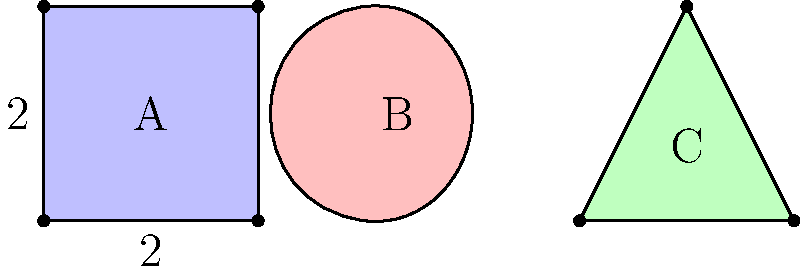In the context of comparing different possible universe configurations in the string theory landscape, consider the three irregular shapes A, B, and C shown above. Shape A is a square with side length 2 units, B is a curved triangle, and C is an isosceles triangle. If the area of shape B is $\frac{3\pi}{4}$ square units, and the area of shape C is $2\sqrt{3}$ square units, rank these shapes in order of increasing area. How does this ranking relate to the concept of comparing different universe configurations in string theory? To solve this problem, we need to calculate or compare the areas of the three shapes:

1. Shape A (Square):
   Area = side length² = 2² = 4 square units

2. Shape B (Curved triangle):
   Given area = $\frac{3\pi}{4}$ ≈ 2.356 square units

3. Shape C (Isosceles triangle):
   Given area = $2\sqrt{3}$ ≈ 3.464 square units

Ranking in order of increasing area:
B < C < A

This ranking relates to comparing different universe configurations in string theory as follows:

1. Each shape represents a possible universe configuration in the string theory landscape.
2. The area of each shape is analogous to a measure of the physical properties or parameters of each universe configuration.
3. Comparing areas is similar to comparing the likelihood or stability of different universe configurations.
4. The ranking shows that some configurations (like B) might be less common or stable, while others (like A) might be more prevalent or stable in the string theory landscape.
5. This analogy helps visualize the concept of a "landscape" of possible universes with varying properties and probabilities.
Answer: B < C < A; analogous to comparing stability/likelihood of universe configurations 